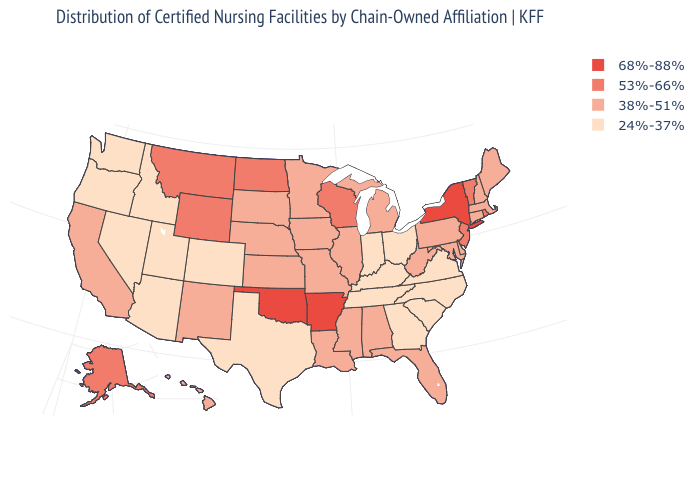Does Oregon have the lowest value in the West?
Be succinct. Yes. Does Kentucky have a lower value than Louisiana?
Keep it brief. Yes. What is the lowest value in the MidWest?
Give a very brief answer. 24%-37%. What is the highest value in states that border Florida?
Answer briefly. 38%-51%. What is the value of Texas?
Write a very short answer. 24%-37%. Does the map have missing data?
Short answer required. No. What is the value of Texas?
Give a very brief answer. 24%-37%. What is the highest value in the USA?
Answer briefly. 68%-88%. What is the lowest value in the MidWest?
Write a very short answer. 24%-37%. What is the value of Illinois?
Be succinct. 38%-51%. What is the highest value in states that border New Hampshire?
Short answer required. 53%-66%. What is the value of New Mexico?
Quick response, please. 38%-51%. Does South Dakota have the lowest value in the USA?
Write a very short answer. No. 